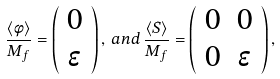Convert formula to latex. <formula><loc_0><loc_0><loc_500><loc_500>\frac { \langle \phi \rangle } { M _ { f } } = \left ( \begin{array} { c } 0 \\ \epsilon \end{array} \right ) , \, a n d \, \frac { \langle S \rangle } { M _ { f } } = \left ( \begin{array} { c c } 0 & 0 \\ 0 & \epsilon \end{array} \right ) ,</formula> 